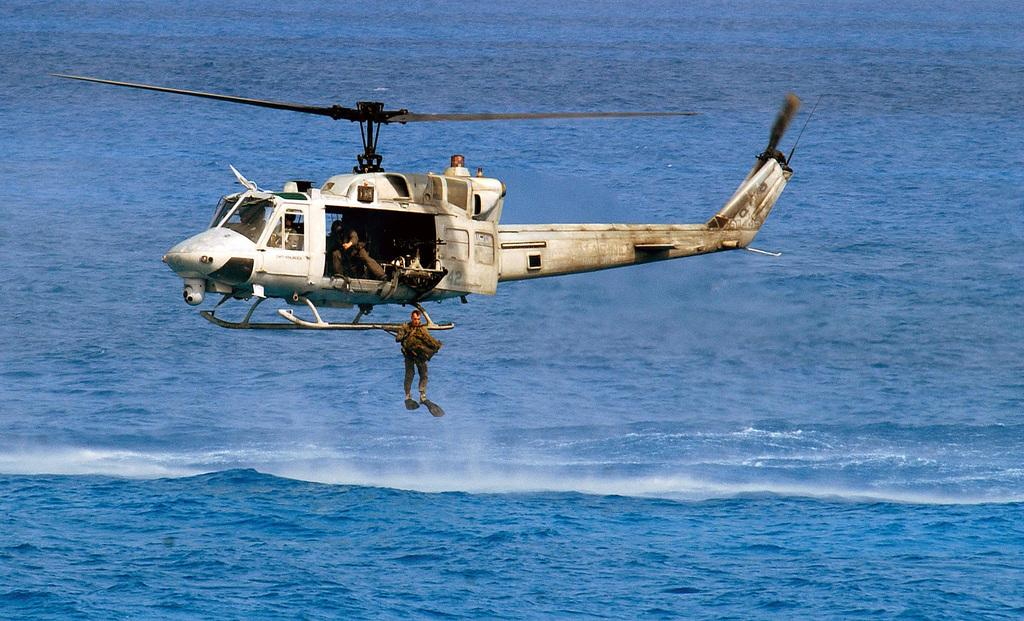What is flying in the air in the image? There is a helicopter in the air in the image. Can you describe the people visible in the image? There are people visible in the image, but their specific actions or features are not discernible. What can be seen in the background of the image? There is water in the background of the image. What type of bean is being knitted into wool in the image? There is no bean or wool present in the image; it features a helicopter in the air and people. 